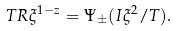<formula> <loc_0><loc_0><loc_500><loc_500>T R \xi ^ { 1 - z } = \Psi _ { \pm } ( I \xi ^ { 2 } / T ) .</formula> 